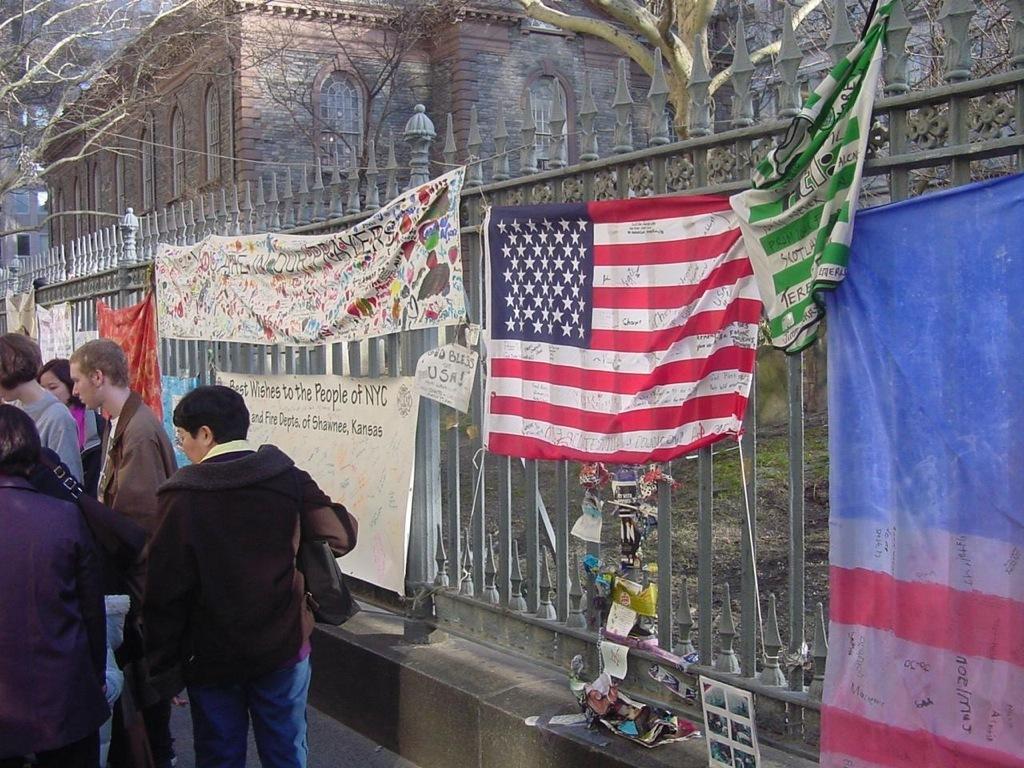How would you summarize this image in a sentence or two? In this picture we can see a group of people standing on the path and on the right side of the people there is a fence and to the fence there are flags and a banner and behind the fence there is a building and trees. 